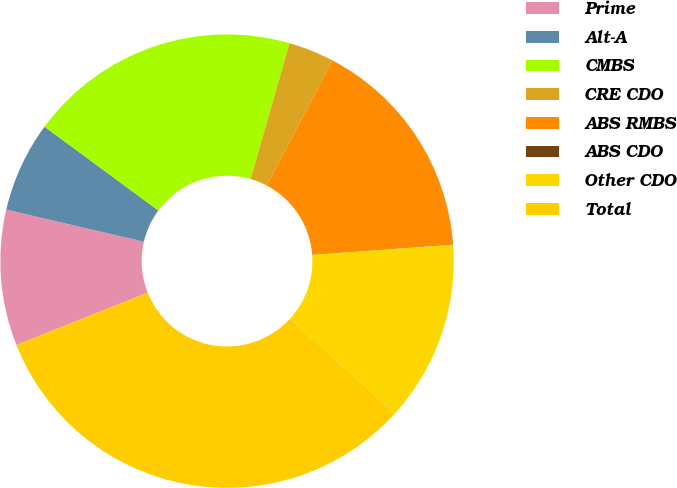Convert chart. <chart><loc_0><loc_0><loc_500><loc_500><pie_chart><fcel>Prime<fcel>Alt-A<fcel>CMBS<fcel>CRE CDO<fcel>ABS RMBS<fcel>ABS CDO<fcel>Other CDO<fcel>Total<nl><fcel>9.68%<fcel>6.46%<fcel>19.34%<fcel>3.24%<fcel>16.12%<fcel>0.03%<fcel>12.9%<fcel>32.22%<nl></chart> 